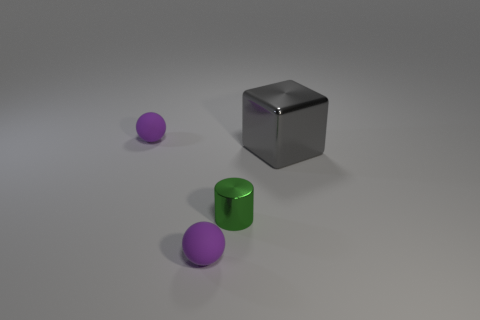Is the number of rubber objects that are left of the green cylinder less than the number of big things that are left of the large metal block?
Ensure brevity in your answer.  No. There is a purple thing that is in front of the small green cylinder; does it have the same shape as the thing that is right of the small green metallic cylinder?
Your answer should be very brief. No. There is a purple matte thing on the right side of the tiny purple object that is behind the big gray metallic thing; what is its shape?
Offer a very short reply. Sphere. Is there a tiny blue cylinder that has the same material as the gray cube?
Your answer should be compact. No. There is a small purple thing that is behind the block; what material is it?
Ensure brevity in your answer.  Rubber. What is the green cylinder made of?
Your response must be concise. Metal. Do the purple thing behind the tiny green thing and the large cube have the same material?
Your response must be concise. No. Are there fewer big gray metal objects that are in front of the small green thing than gray objects?
Ensure brevity in your answer.  Yes. How many big shiny objects are the same shape as the small green object?
Make the answer very short. 0. There is a tiny matte object that is behind the green cylinder; what is its color?
Provide a short and direct response. Purple. 